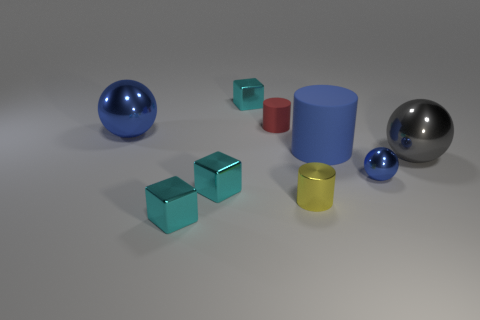There is a shiny thing behind the big blue metal ball; does it have the same color as the ball in front of the gray shiny thing?
Your response must be concise. No. There is a small metal thing that is right of the red cylinder and on the left side of the small blue ball; what shape is it?
Ensure brevity in your answer.  Cylinder. Is there a tiny green rubber object of the same shape as the big gray thing?
Make the answer very short. No. There is a blue thing that is the same size as the blue rubber cylinder; what is its shape?
Make the answer very short. Sphere. What is the tiny red object made of?
Offer a terse response. Rubber. What size is the cyan shiny thing behind the big blue object that is on the left side of the small cyan thing that is behind the small blue shiny thing?
Your response must be concise. Small. What is the material of the big object that is the same color as the large rubber cylinder?
Offer a very short reply. Metal. How many shiny things are tiny objects or tiny green cylinders?
Offer a terse response. 5. How big is the blue cylinder?
Your answer should be compact. Large. How many objects are gray metal balls or gray things in front of the small red thing?
Offer a terse response. 1. 